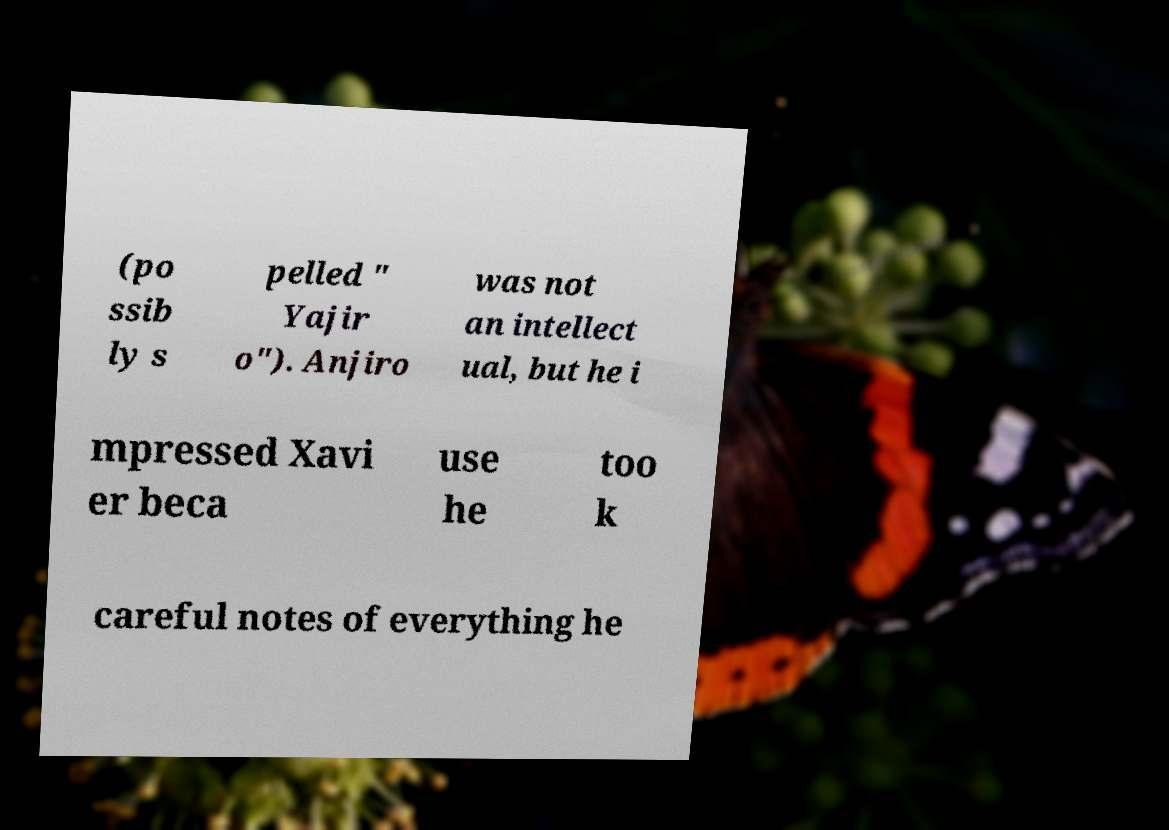Could you extract and type out the text from this image? (po ssib ly s pelled " Yajir o"). Anjiro was not an intellect ual, but he i mpressed Xavi er beca use he too k careful notes of everything he 